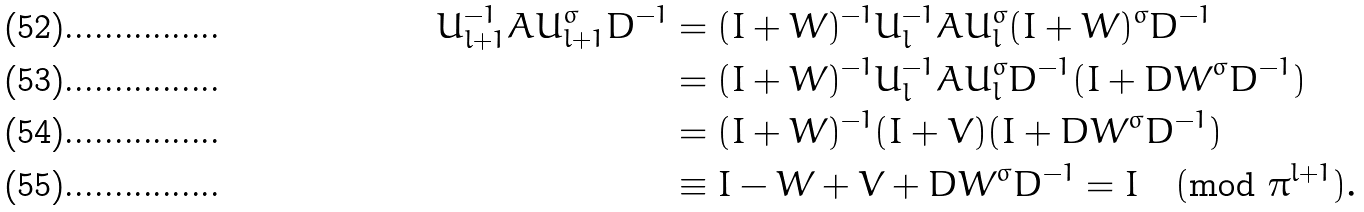<formula> <loc_0><loc_0><loc_500><loc_500>U _ { l + 1 } ^ { - 1 } A U _ { l + 1 } ^ { \sigma } D ^ { - 1 } & = ( I + W ) ^ { - 1 } U _ { l } ^ { - 1 } A U _ { l } ^ { \sigma } ( I + W ) ^ { \sigma } D ^ { - 1 } \\ & = ( I + W ) ^ { - 1 } U _ { l } ^ { - 1 } A U _ { l } ^ { \sigma } D ^ { - 1 } ( I + D W ^ { \sigma } D ^ { - 1 } ) \\ & = ( I + W ) ^ { - 1 } ( I + V ) ( I + D W ^ { \sigma } D ^ { - 1 } ) \\ & \equiv I - W + V + D W ^ { \sigma } D ^ { - 1 } = I \pmod { \pi ^ { l + 1 } } .</formula> 